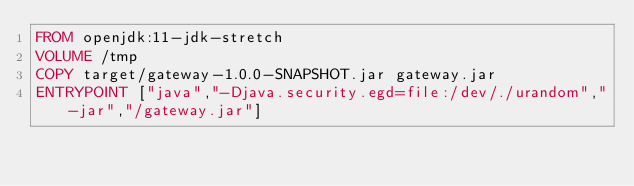Convert code to text. <code><loc_0><loc_0><loc_500><loc_500><_Dockerfile_>FROM openjdk:11-jdk-stretch
VOLUME /tmp
COPY target/gateway-1.0.0-SNAPSHOT.jar gateway.jar
ENTRYPOINT ["java","-Djava.security.egd=file:/dev/./urandom","-jar","/gateway.jar"]
</code> 